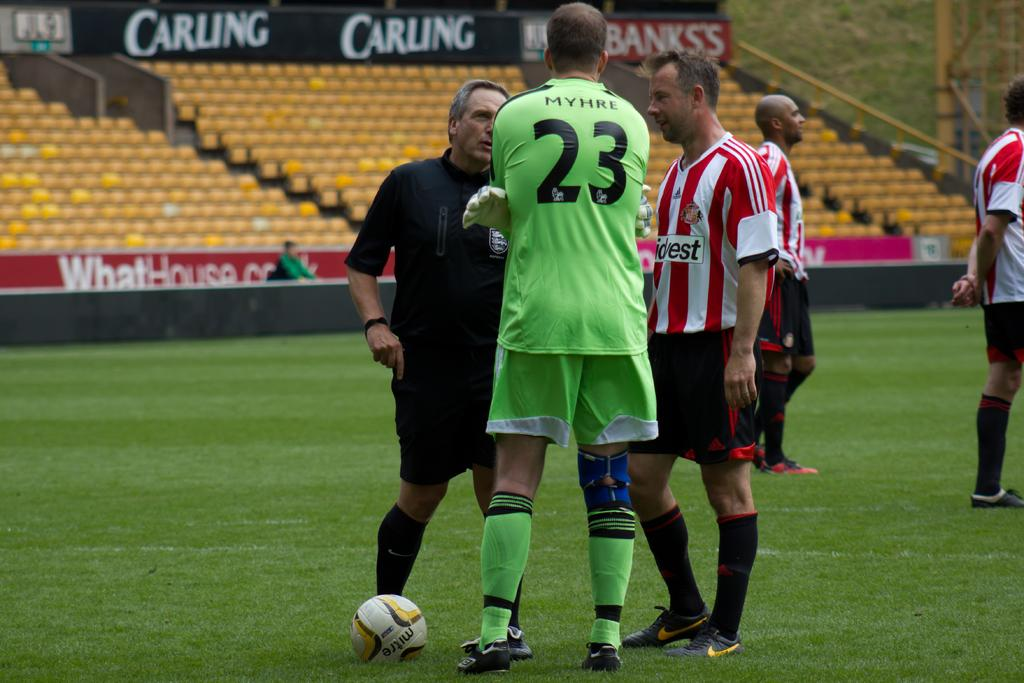What are the people in the image doing? The people in the image are standing in the grass. What object can be seen in the image besides the people? There is a ball in the image. What can be seen in the background of the image? There are chairs and an advertisement board in the background of the image. What type of fuel is being pumped into the ball in the image? There is no fuel or pump present in the image; it features people standing in the grass with a ball. 